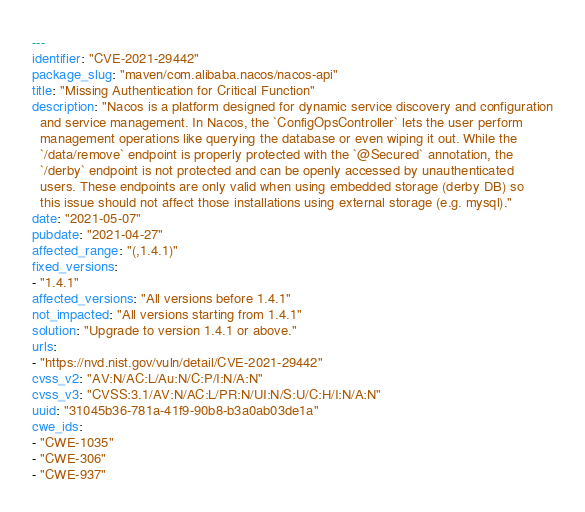Convert code to text. <code><loc_0><loc_0><loc_500><loc_500><_YAML_>---
identifier: "CVE-2021-29442"
package_slug: "maven/com.alibaba.nacos/nacos-api"
title: "Missing Authentication for Critical Function"
description: "Nacos is a platform designed for dynamic service discovery and configuration
  and service management. In Nacos, the `ConfigOpsController` lets the user perform
  management operations like querying the database or even wiping it out. While the
  `/data/remove` endpoint is properly protected with the `@Secured` annotation, the
  `/derby` endpoint is not protected and can be openly accessed by unauthenticated
  users. These endpoints are only valid when using embedded storage (derby DB) so
  this issue should not affect those installations using external storage (e.g. mysql)."
date: "2021-05-07"
pubdate: "2021-04-27"
affected_range: "(,1.4.1)"
fixed_versions:
- "1.4.1"
affected_versions: "All versions before 1.4.1"
not_impacted: "All versions starting from 1.4.1"
solution: "Upgrade to version 1.4.1 or above."
urls:
- "https://nvd.nist.gov/vuln/detail/CVE-2021-29442"
cvss_v2: "AV:N/AC:L/Au:N/C:P/I:N/A:N"
cvss_v3: "CVSS:3.1/AV:N/AC:L/PR:N/UI:N/S:U/C:H/I:N/A:N"
uuid: "31045b36-781a-41f9-90b8-b3a0ab03de1a"
cwe_ids:
- "CWE-1035"
- "CWE-306"
- "CWE-937"
</code> 